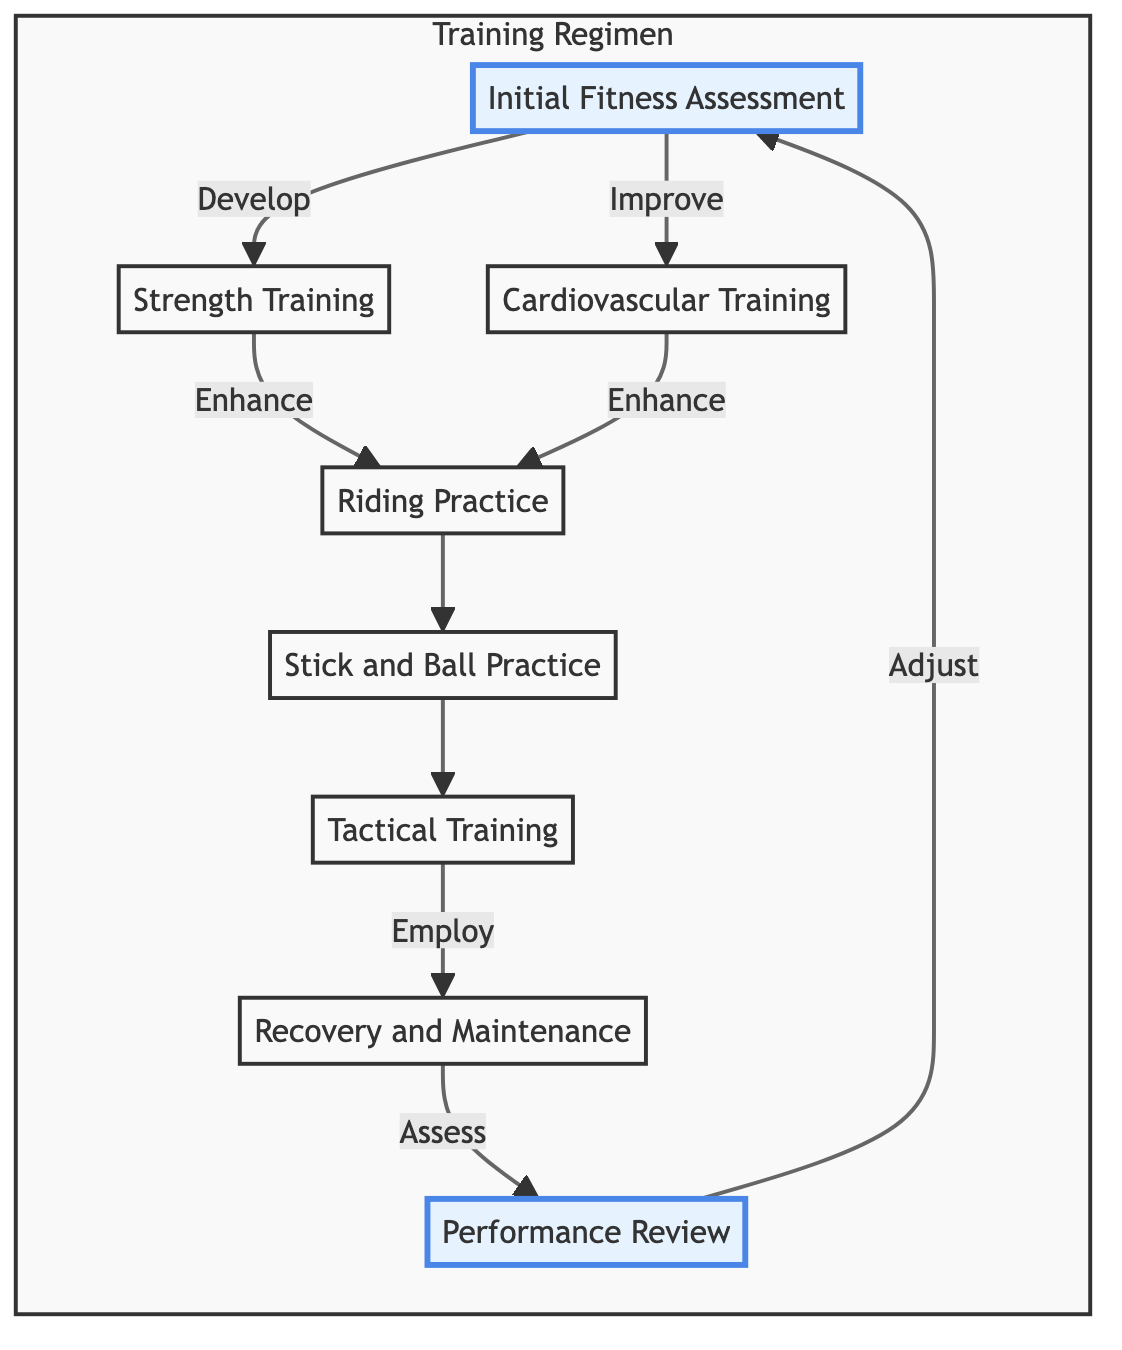What is the first step in the training regimen? The diagram starts with the node labeled "Initial Fitness Assessment," indicating it is the first step in the training regimen.
Answer: Initial Fitness Assessment How many main training components are there? The diagram shows eight nodes, each representing a distinct component of the training regimen, confirming that there are eight main components.
Answer: 8 Which node follows 'Riding Practice'? According to the diagram, after 'Riding Practice' (node D), the next node is 'Stick and Ball Practice' (node E), showing the sequential flow from one training component to the next.
Answer: Stick and Ball Practice What is the final step in the training regimen? The last node in the flowchart is "Performance Review," which indicates it is the final step in the training process before adjustments are made.
Answer: Performance Review Which two nodes are directly connected to the 'Initial Fitness Assessment'? The connections from the 'Initial Fitness Assessment' node (A) lead directly to 'Strength Training' (B) and 'Cardiovascular Training' (C), indicating these are the two nodes that follow from the initial assessment.
Answer: Strength Training and Cardiovascular Training What is the purpose of 'Tactical Training'? The description of 'Tactical Training' explains it focuses on understanding and practicing strategies: "Understand and practice game strategies, team coordination, and decision-making under pressure." This reveals its underlying purpose utilized by players during games.
Answer: Game strategies How does the diagram define 'Recovery and Maintenance'? 'Recovery and Maintenance' is defined in the diagram as employing techniques to prevent injuries, indicating its role in ensuring long-term athletic health.
Answer: Prevent injuries What connects the 'Recovery and Maintenance' step to the next action? The diagram shows that the 'Recovery and Maintenance' node (G) connects to 'Performance Review' (H), indicating that recovery leads to assessing performance improvements next.
Answer: Performance Review 